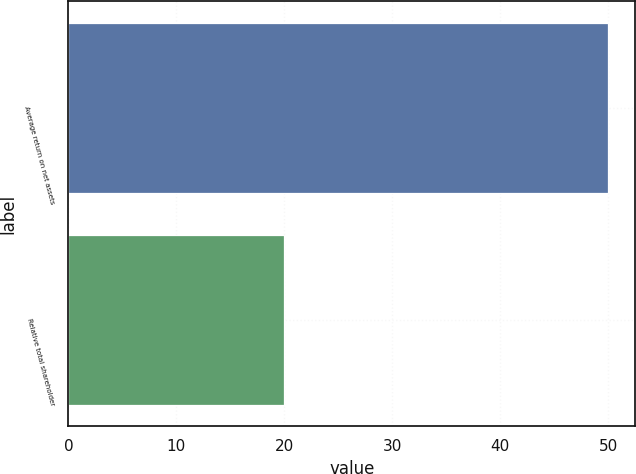<chart> <loc_0><loc_0><loc_500><loc_500><bar_chart><fcel>Average return on net assets<fcel>Relative total shareholder<nl><fcel>50<fcel>20<nl></chart> 